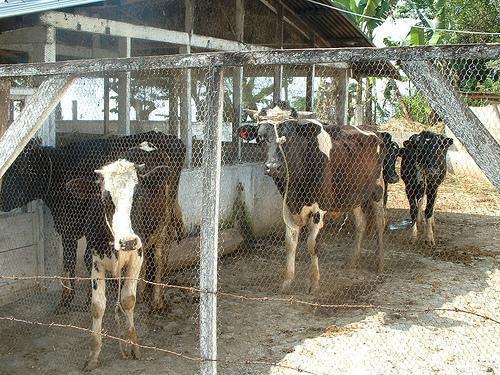The nearby cow to the left who is looking at the camera wears what color down his face?
Select the accurate answer and provide explanation: 'Answer: answer
Rationale: rationale.'
Options: White, brown, black, gray. Answer: white.
Rationale: The cow has this light color against his black spots. 